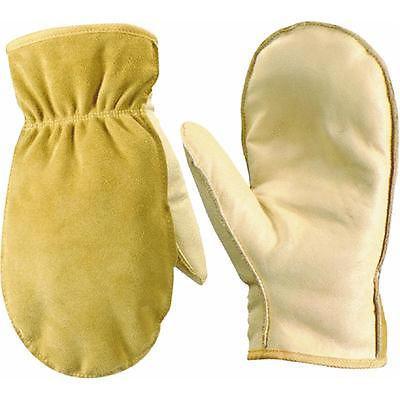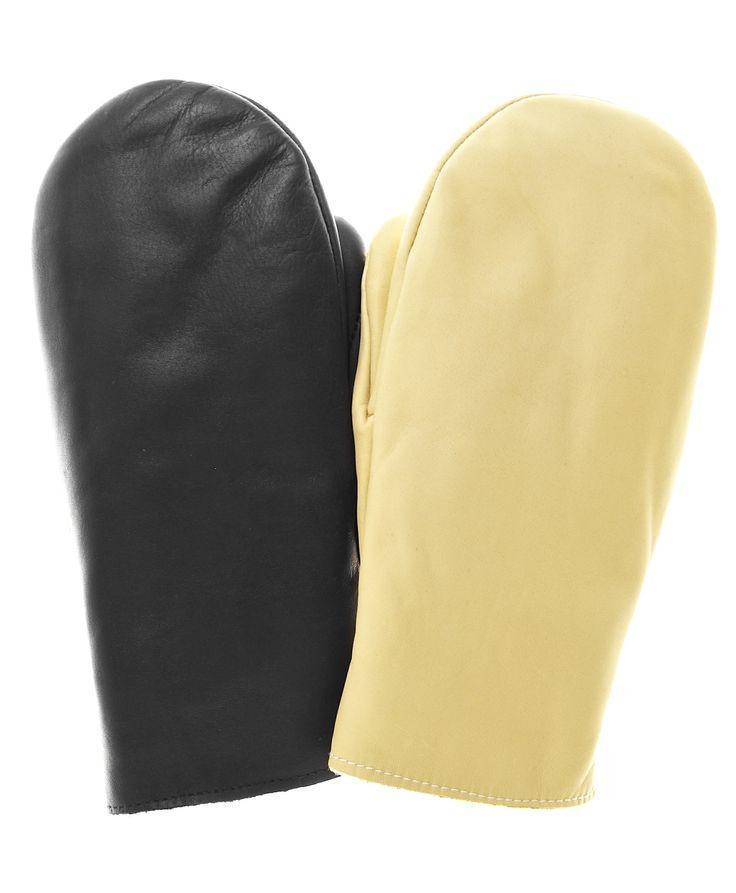The first image is the image on the left, the second image is the image on the right. Analyze the images presented: Is the assertion "There are three mittens in the image on the left and a single pair in the image on the right." valid? Answer yes or no. No. The first image is the image on the left, the second image is the image on the right. For the images displayed, is the sentence "One image shows exactly one buff beige mitten overlapping one black mitten." factually correct? Answer yes or no. Yes. 